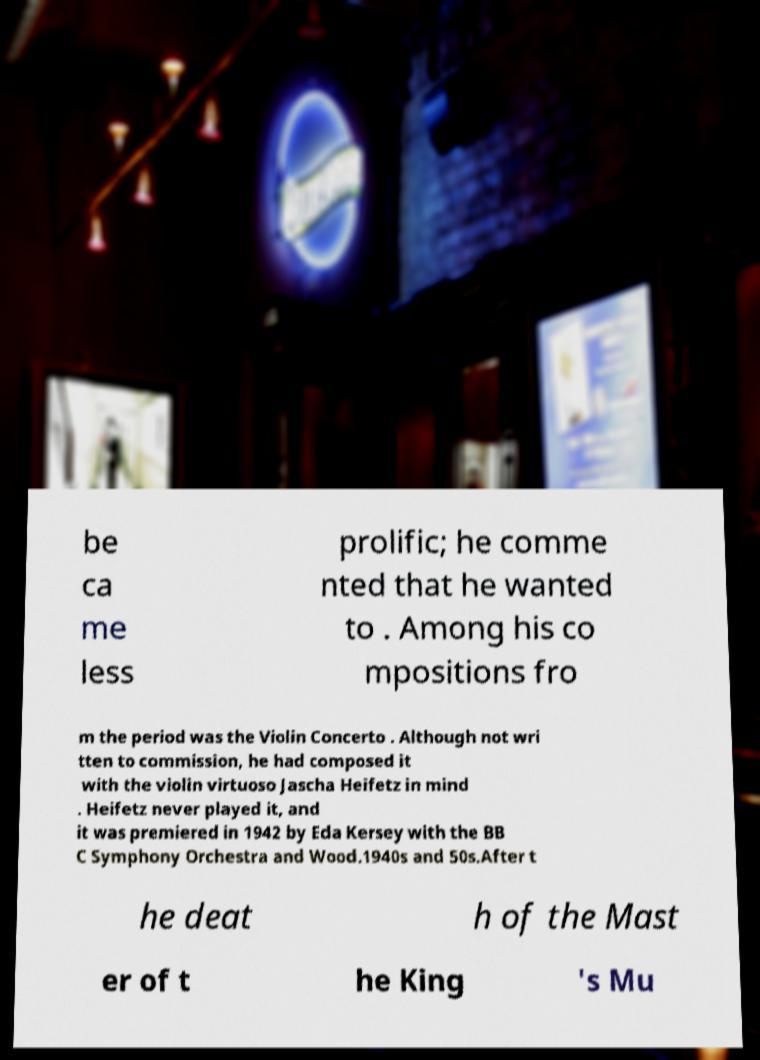Could you extract and type out the text from this image? be ca me less prolific; he comme nted that he wanted to . Among his co mpositions fro m the period was the Violin Concerto . Although not wri tten to commission, he had composed it with the violin virtuoso Jascha Heifetz in mind . Heifetz never played it, and it was premiered in 1942 by Eda Kersey with the BB C Symphony Orchestra and Wood.1940s and 50s.After t he deat h of the Mast er of t he King 's Mu 